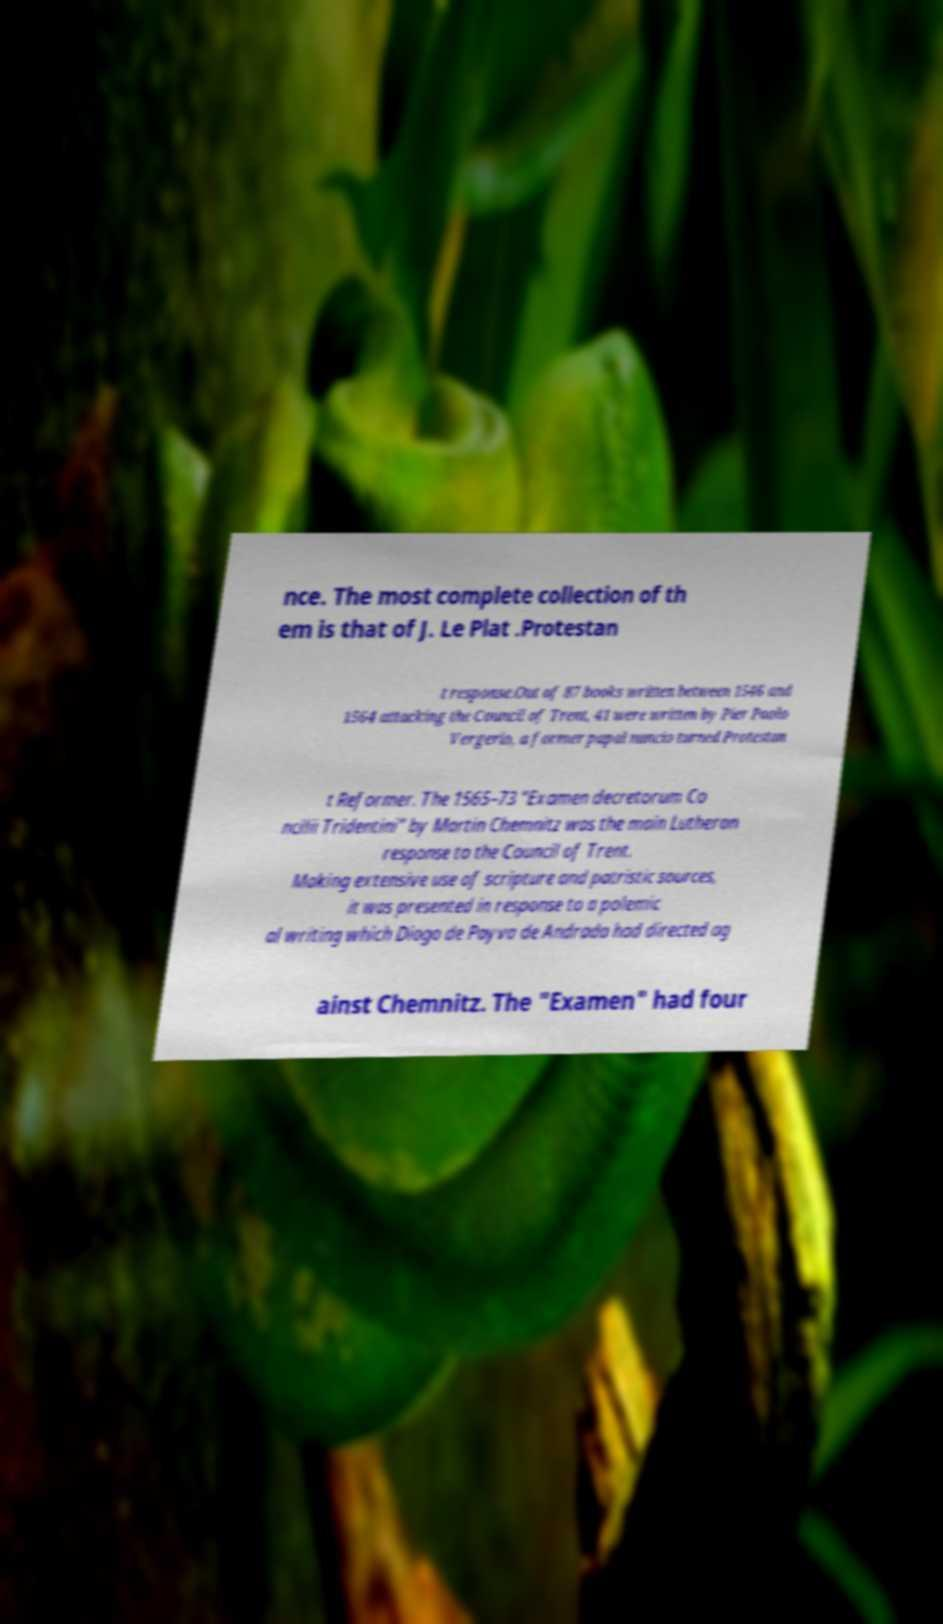What messages or text are displayed in this image? I need them in a readable, typed format. nce. The most complete collection of th em is that of J. Le Plat .Protestan t response.Out of 87 books written between 1546 and 1564 attacking the Council of Trent, 41 were written by Pier Paolo Vergerio, a former papal nuncio turned Protestan t Reformer. The 1565–73 "Examen decretorum Co ncilii Tridentini" by Martin Chemnitz was the main Lutheran response to the Council of Trent. Making extensive use of scripture and patristic sources, it was presented in response to a polemic al writing which Diogo de Payva de Andrada had directed ag ainst Chemnitz. The "Examen" had four 